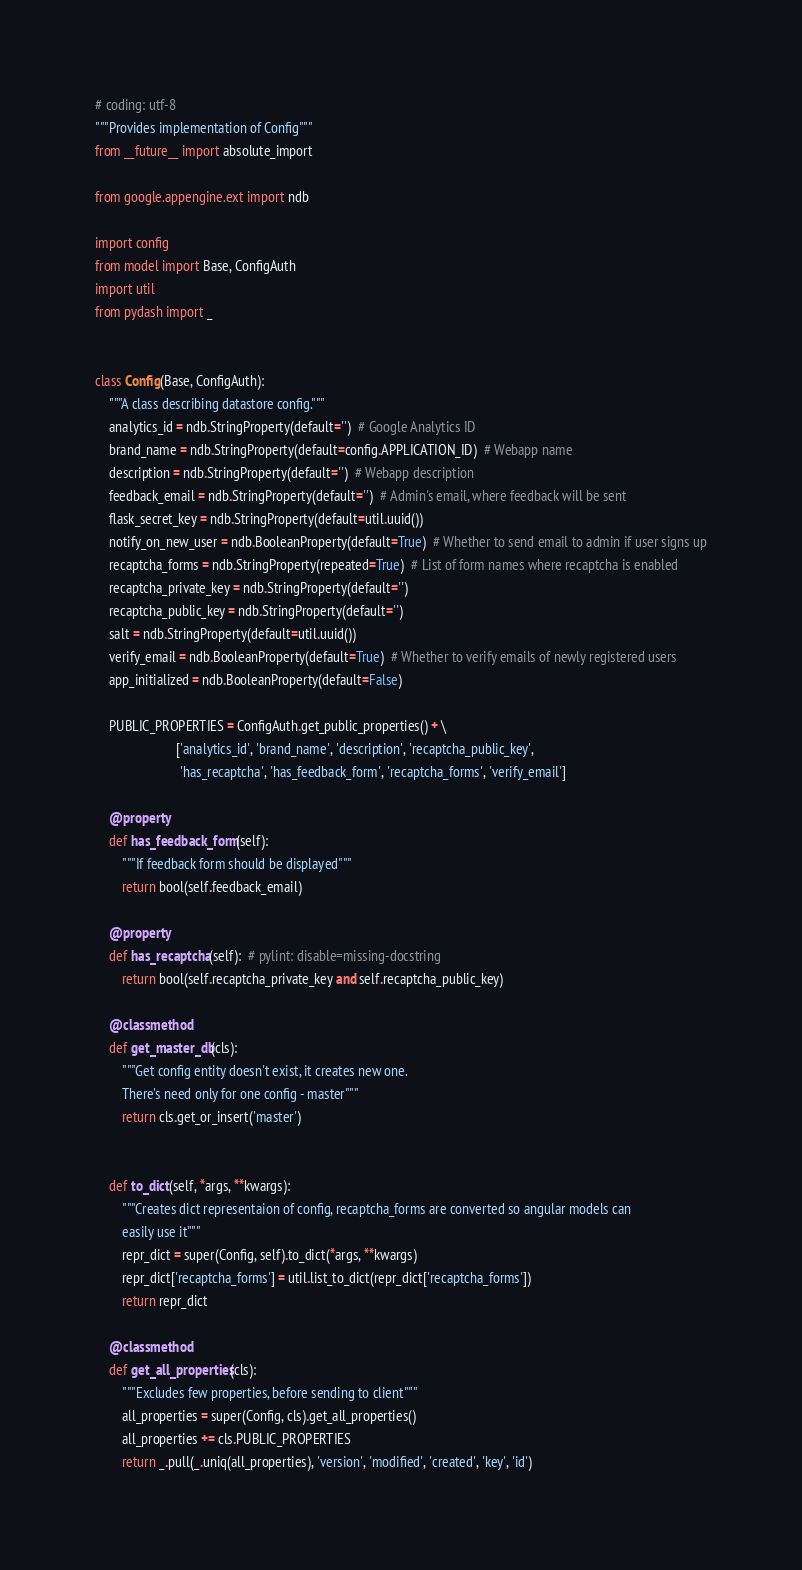<code> <loc_0><loc_0><loc_500><loc_500><_Python_># coding: utf-8
"""Provides implementation of Config"""
from __future__ import absolute_import

from google.appengine.ext import ndb

import config
from model import Base, ConfigAuth
import util
from pydash import _


class Config(Base, ConfigAuth):
    """A class describing datastore config."""
    analytics_id = ndb.StringProperty(default='')  # Google Analytics ID
    brand_name = ndb.StringProperty(default=config.APPLICATION_ID)  # Webapp name
    description = ndb.StringProperty(default='')  # Webapp description
    feedback_email = ndb.StringProperty(default='')  # Admin's email, where feedback will be sent
    flask_secret_key = ndb.StringProperty(default=util.uuid())
    notify_on_new_user = ndb.BooleanProperty(default=True)  # Whether to send email to admin if user signs up
    recaptcha_forms = ndb.StringProperty(repeated=True)  # List of form names where recaptcha is enabled
    recaptcha_private_key = ndb.StringProperty(default='')
    recaptcha_public_key = ndb.StringProperty(default='')
    salt = ndb.StringProperty(default=util.uuid())
    verify_email = ndb.BooleanProperty(default=True)  # Whether to verify emails of newly registered users
    app_initialized = ndb.BooleanProperty(default=False)

    PUBLIC_PROPERTIES = ConfigAuth.get_public_properties() + \
                        ['analytics_id', 'brand_name', 'description', 'recaptcha_public_key',
                         'has_recaptcha', 'has_feedback_form', 'recaptcha_forms', 'verify_email']

    @property
    def has_feedback_form(self):
        """If feedback form should be displayed"""
        return bool(self.feedback_email)

    @property
    def has_recaptcha(self):  # pylint: disable=missing-docstring
        return bool(self.recaptcha_private_key and self.recaptcha_public_key)

    @classmethod
    def get_master_db(cls):
        """Get config entity doesn't exist, it creates new one.
        There's need only for one config - master"""
        return cls.get_or_insert('master')


    def to_dict(self, *args, **kwargs):
        """Creates dict representaion of config, recaptcha_forms are converted so angular models can
        easily use it"""
        repr_dict = super(Config, self).to_dict(*args, **kwargs)
        repr_dict['recaptcha_forms'] = util.list_to_dict(repr_dict['recaptcha_forms'])
        return repr_dict

    @classmethod
    def get_all_properties(cls):
        """Excludes few properties, before sending to client"""
        all_properties = super(Config, cls).get_all_properties()
        all_properties += cls.PUBLIC_PROPERTIES
        return _.pull(_.uniq(all_properties), 'version', 'modified', 'created', 'key', 'id')
</code> 